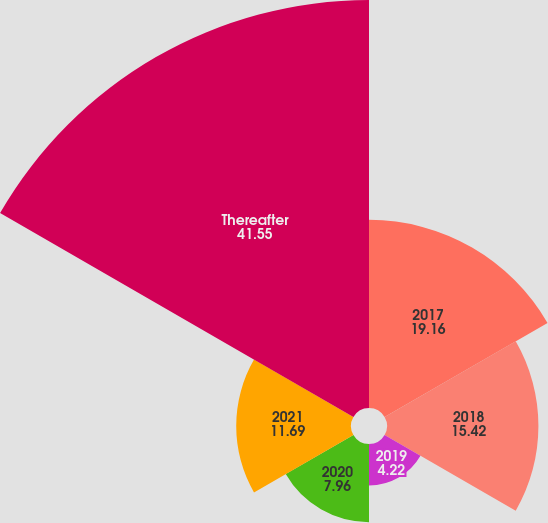Convert chart to OTSL. <chart><loc_0><loc_0><loc_500><loc_500><pie_chart><fcel>2017<fcel>2018<fcel>2019<fcel>2020<fcel>2021<fcel>Thereafter<nl><fcel>19.16%<fcel>15.42%<fcel>4.22%<fcel>7.96%<fcel>11.69%<fcel>41.55%<nl></chart> 